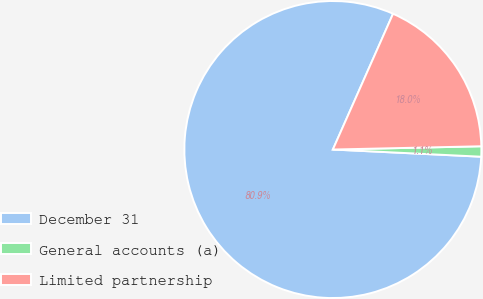<chart> <loc_0><loc_0><loc_500><loc_500><pie_chart><fcel>December 31<fcel>General accounts (a)<fcel>Limited partnership<nl><fcel>80.87%<fcel>1.12%<fcel>18.01%<nl></chart> 